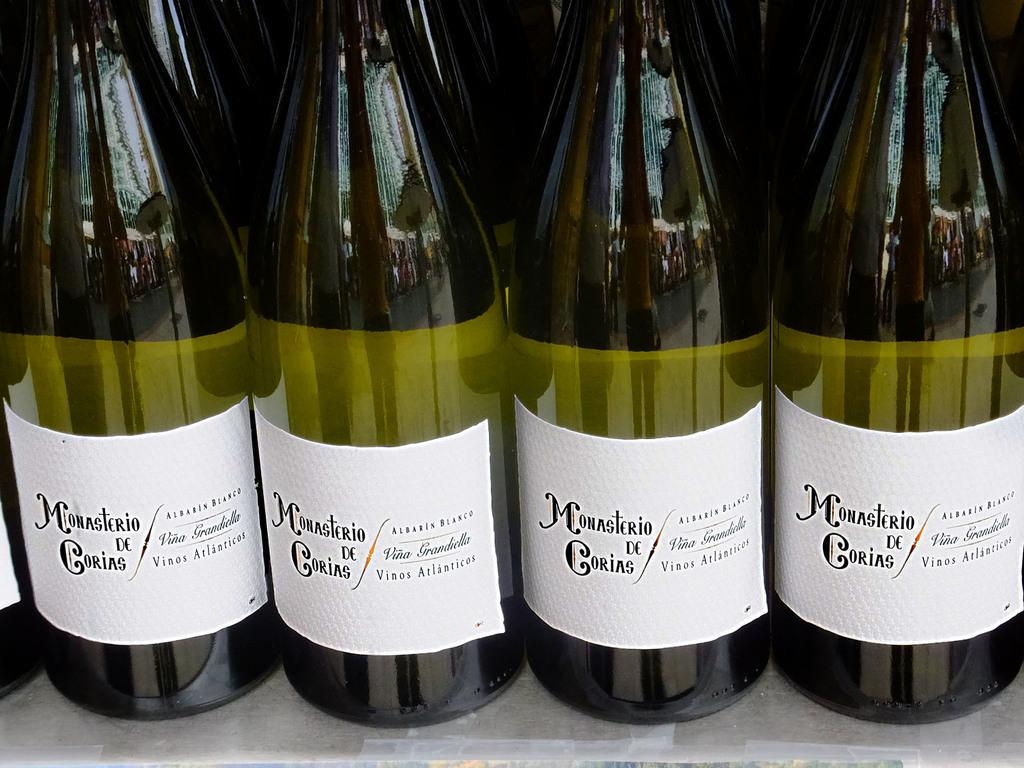Provide a one-sentence caption for the provided image. Alcohol bottle with a label that says "Monasterio de Corias". 